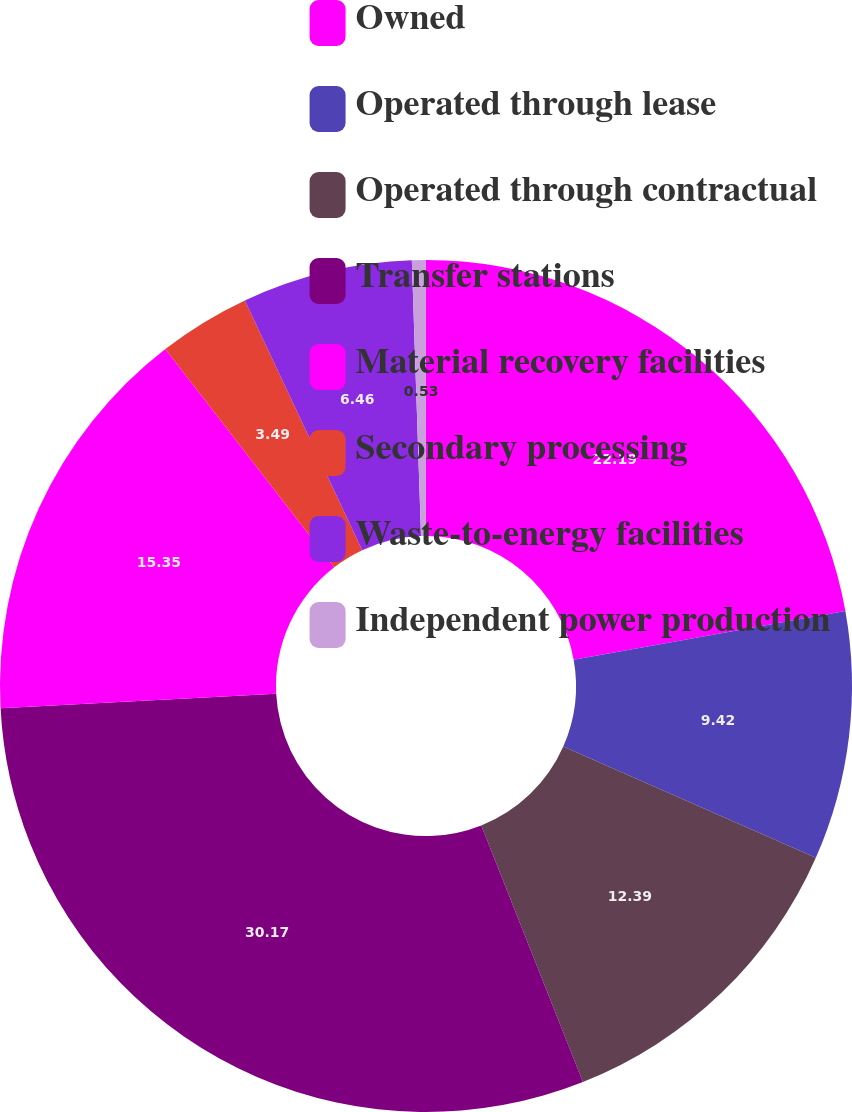Convert chart to OTSL. <chart><loc_0><loc_0><loc_500><loc_500><pie_chart><fcel>Owned<fcel>Operated through lease<fcel>Operated through contractual<fcel>Transfer stations<fcel>Material recovery facilities<fcel>Secondary processing<fcel>Waste-to-energy facilities<fcel>Independent power production<nl><fcel>22.19%<fcel>9.42%<fcel>12.39%<fcel>30.18%<fcel>15.35%<fcel>3.49%<fcel>6.46%<fcel>0.53%<nl></chart> 